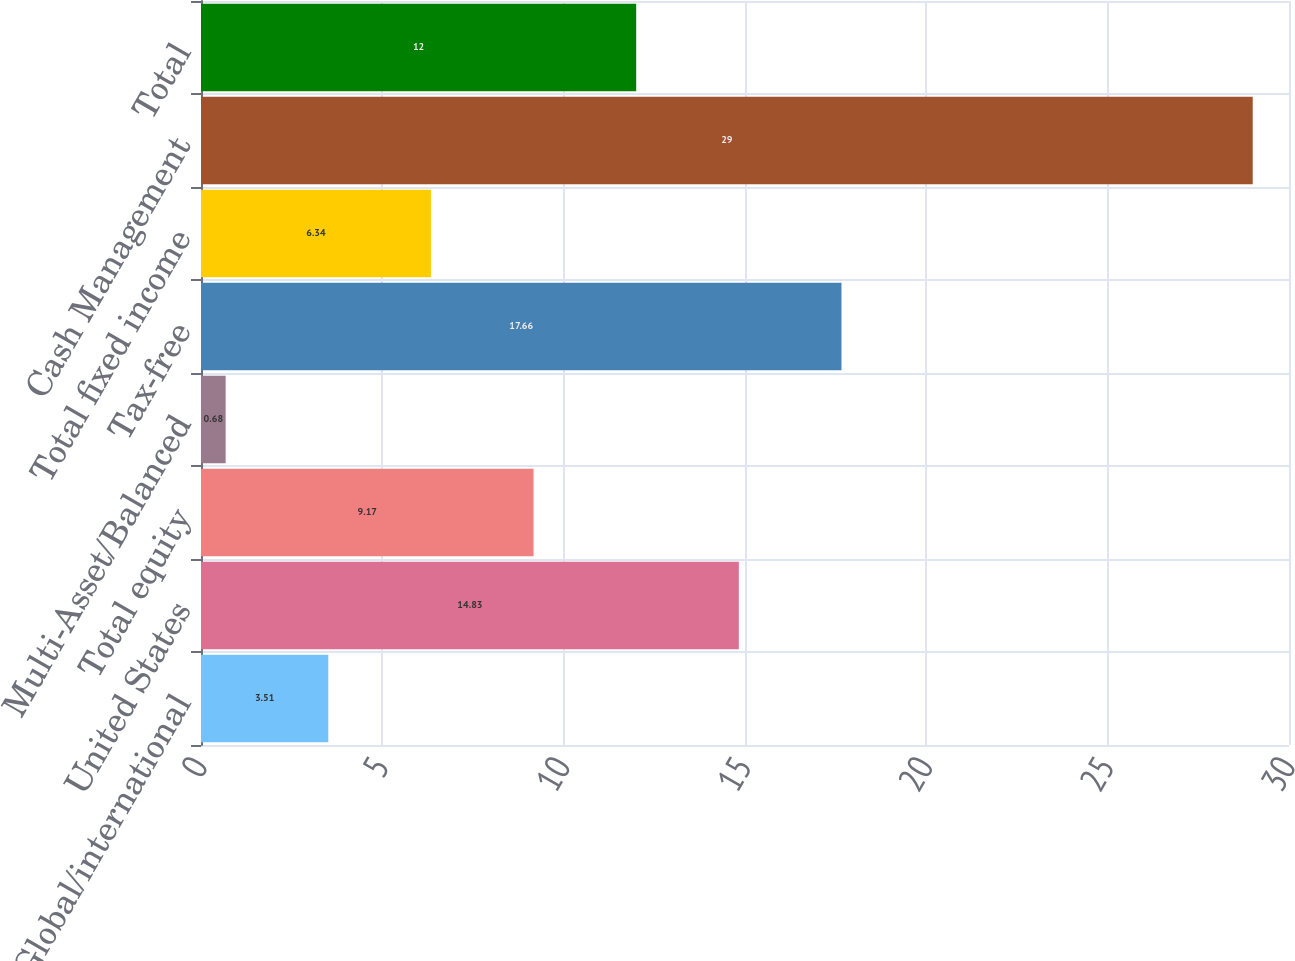Convert chart to OTSL. <chart><loc_0><loc_0><loc_500><loc_500><bar_chart><fcel>Global/international<fcel>United States<fcel>Total equity<fcel>Multi-Asset/Balanced<fcel>Tax-free<fcel>Total fixed income<fcel>Cash Management<fcel>Total<nl><fcel>3.51<fcel>14.83<fcel>9.17<fcel>0.68<fcel>17.66<fcel>6.34<fcel>29<fcel>12<nl></chart> 